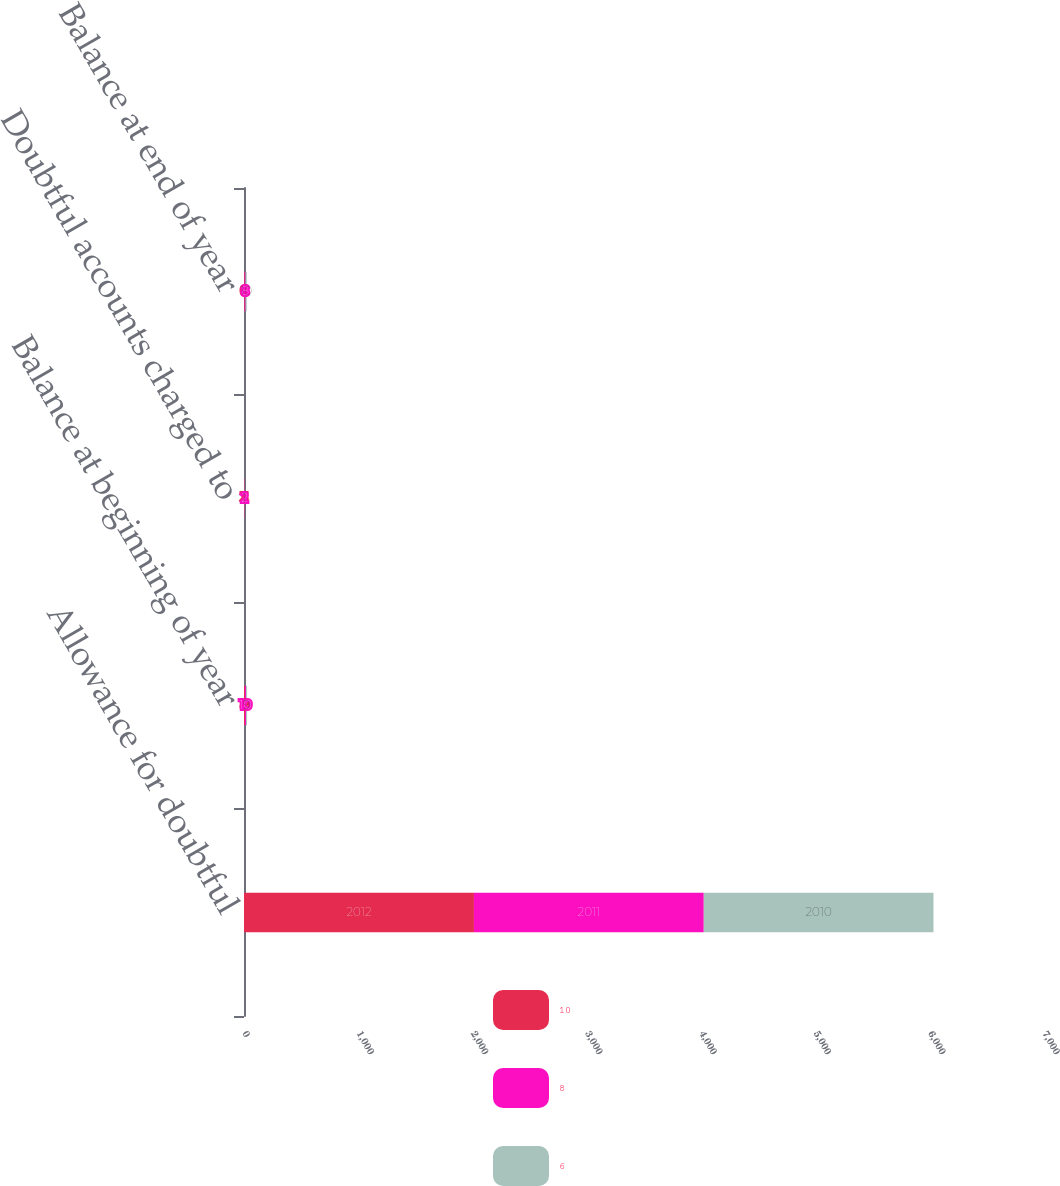Convert chart. <chart><loc_0><loc_0><loc_500><loc_500><stacked_bar_chart><ecel><fcel>Allowance for doubtful<fcel>Balance at beginning of year<fcel>Doubtful accounts charged to<fcel>Balance at end of year<nl><fcel>10<fcel>2012<fcel>8<fcel>3<fcel>6<nl><fcel>8<fcel>2011<fcel>10<fcel>2<fcel>8<nl><fcel>6<fcel>2010<fcel>9<fcel>1<fcel>10<nl></chart> 